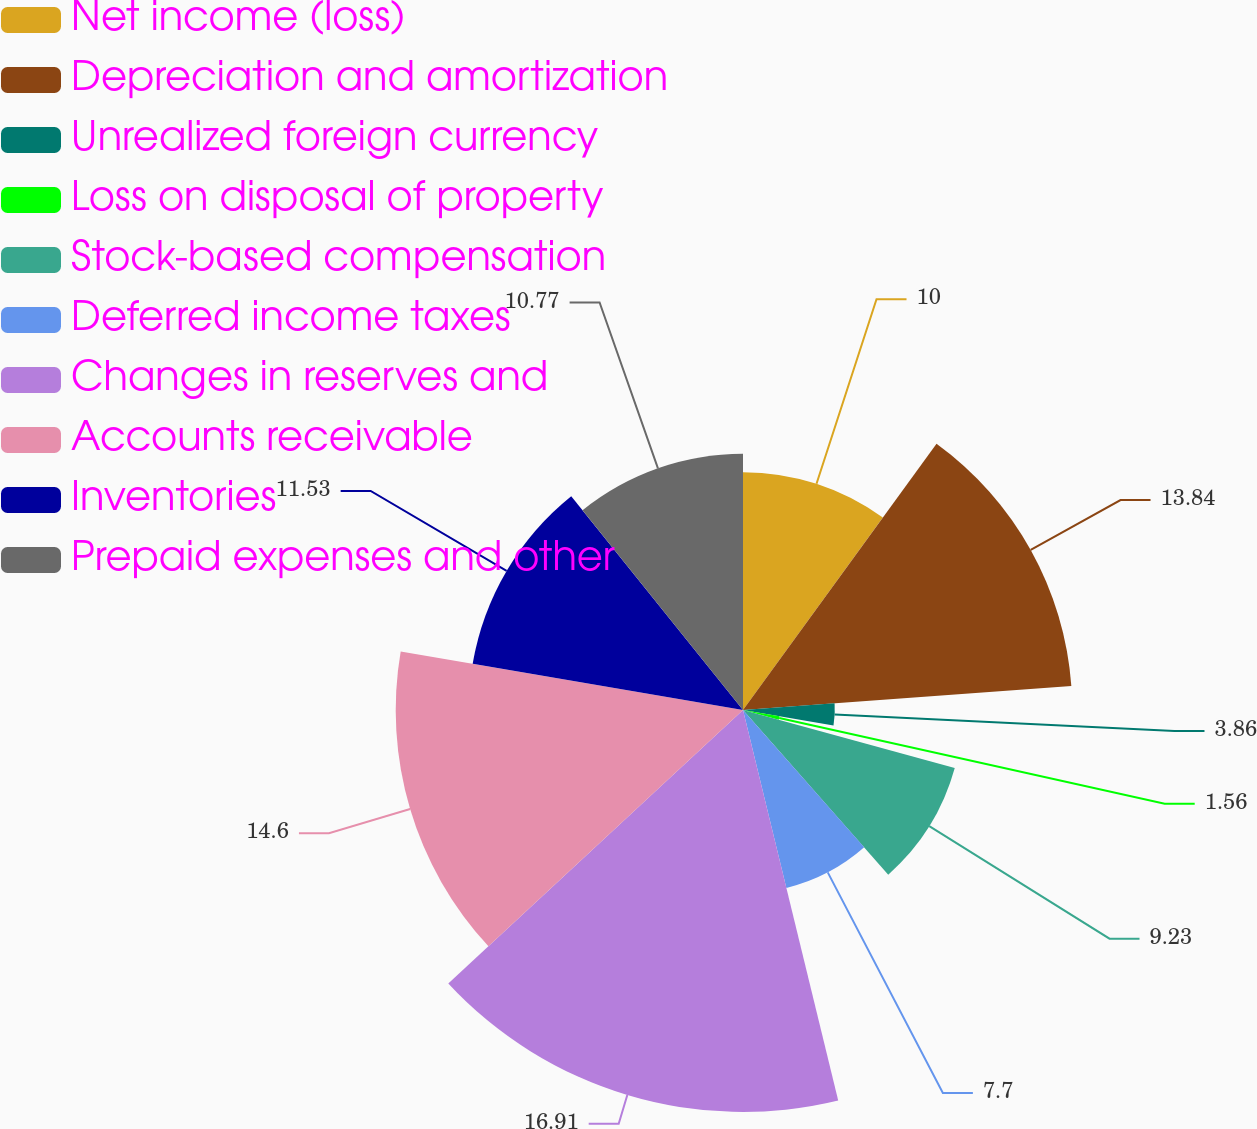<chart> <loc_0><loc_0><loc_500><loc_500><pie_chart><fcel>Net income (loss)<fcel>Depreciation and amortization<fcel>Unrealized foreign currency<fcel>Loss on disposal of property<fcel>Stock-based compensation<fcel>Deferred income taxes<fcel>Changes in reserves and<fcel>Accounts receivable<fcel>Inventories<fcel>Prepaid expenses and other<nl><fcel>10.0%<fcel>13.84%<fcel>3.86%<fcel>1.56%<fcel>9.23%<fcel>7.7%<fcel>16.9%<fcel>14.6%<fcel>11.53%<fcel>10.77%<nl></chart> 